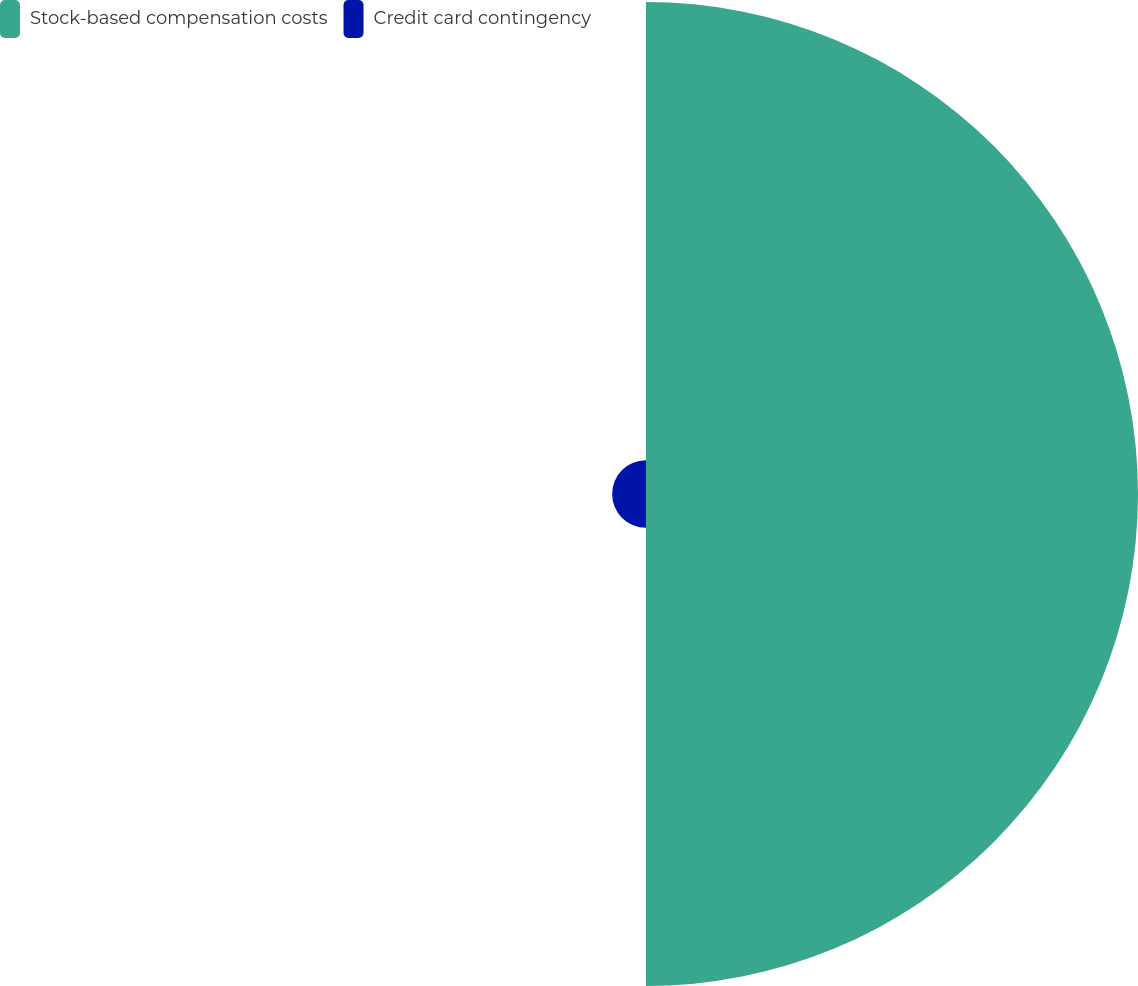<chart> <loc_0><loc_0><loc_500><loc_500><pie_chart><fcel>Stock-based compensation costs<fcel>Credit card contingency<nl><fcel>93.56%<fcel>6.44%<nl></chart> 